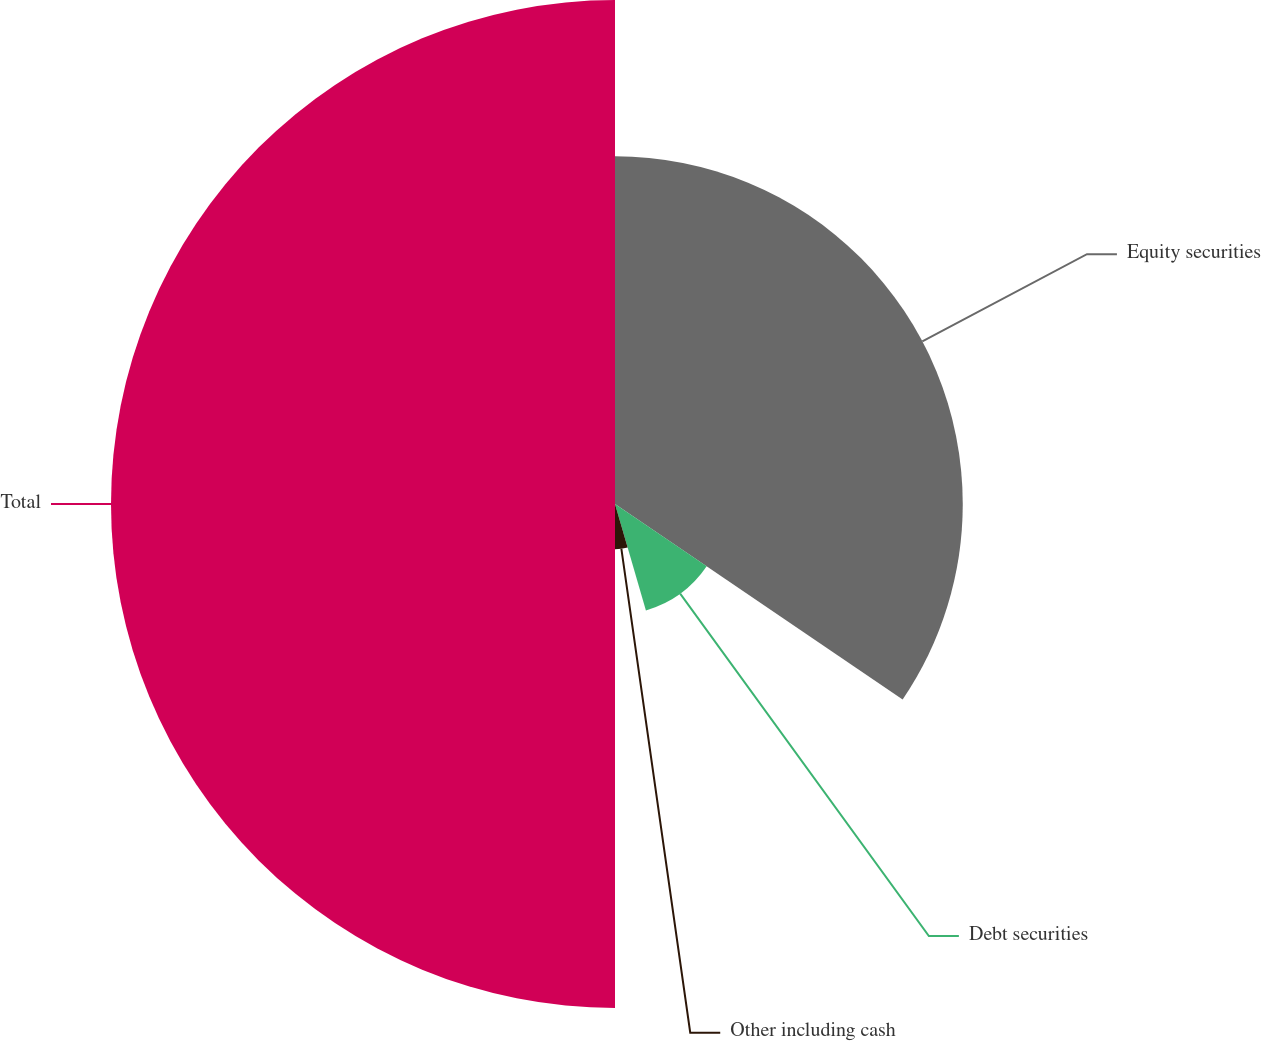<chart> <loc_0><loc_0><loc_500><loc_500><pie_chart><fcel>Equity securities<fcel>Debt securities<fcel>Other including cash<fcel>Total<nl><fcel>34.5%<fcel>11.0%<fcel>4.5%<fcel>50.0%<nl></chart> 